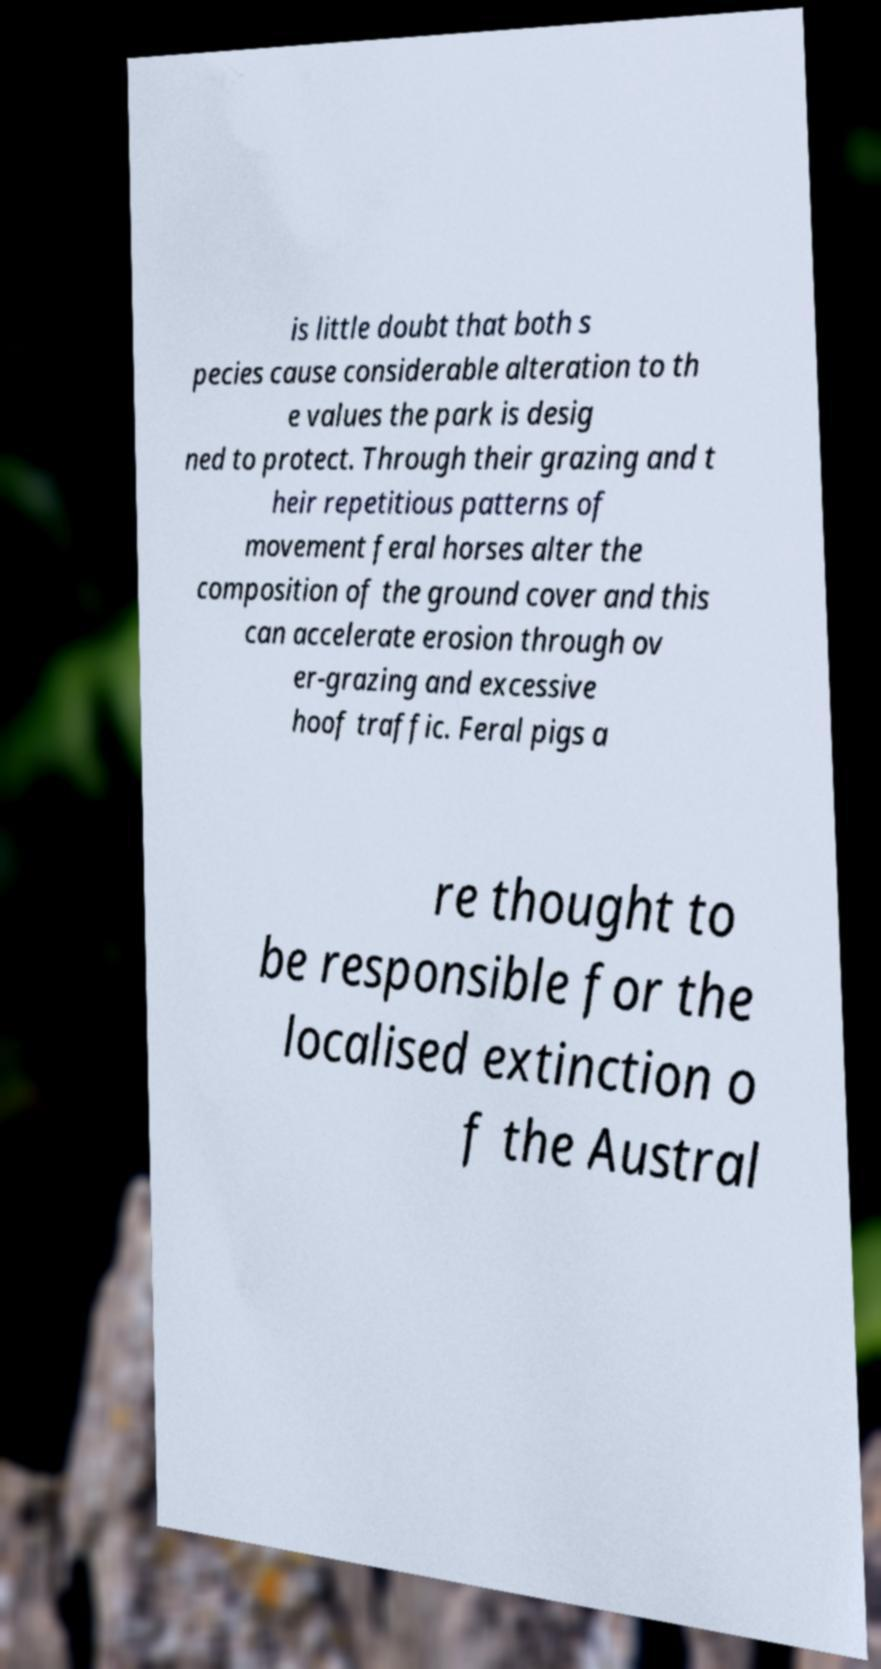I need the written content from this picture converted into text. Can you do that? is little doubt that both s pecies cause considerable alteration to th e values the park is desig ned to protect. Through their grazing and t heir repetitious patterns of movement feral horses alter the composition of the ground cover and this can accelerate erosion through ov er-grazing and excessive hoof traffic. Feral pigs a re thought to be responsible for the localised extinction o f the Austral 